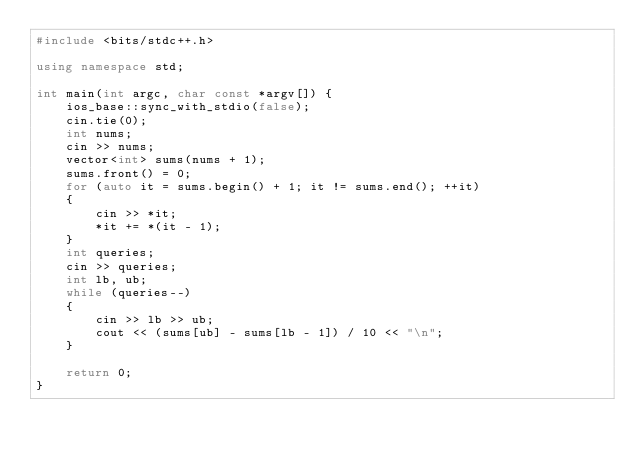<code> <loc_0><loc_0><loc_500><loc_500><_C++_>#include <bits/stdc++.h>

using namespace std;

int main(int argc, char const *argv[]) {
    ios_base::sync_with_stdio(false);
    cin.tie(0);
    int nums;
    cin >> nums;
    vector<int> sums(nums + 1);
    sums.front() = 0;
    for (auto it = sums.begin() + 1; it != sums.end(); ++it)
    {
        cin >> *it;
        *it += *(it - 1);
    }
    int queries;
    cin >> queries;
    int lb, ub;
    while (queries--)
    {
        cin >> lb >> ub;
        cout << (sums[ub] - sums[lb - 1]) / 10 << "\n";
    }

    return 0;
}
</code> 